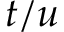<formula> <loc_0><loc_0><loc_500><loc_500>t / u</formula> 